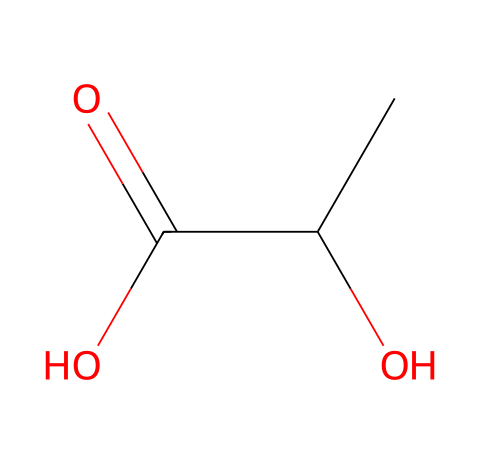What is the name of this chemical? This chemical structure represents lactic acid, which is a common organic acid produced during anaerobic respiration in muscles during intense exercise.
Answer: lactic acid How many carbon atoms are present in lactic acid? By examining the chemical structure, we notice that there are three carbon atoms indicated by the 'C' symbols.
Answer: three What type of functional group is present in lactic acid? The presence of the -COOH group (carboxylic acid) indicates that lactic acid is an acid; this is a characteristic functional group in organic acids.
Answer: carboxylic acid What is the total number of oxygen atoms in lactic acid? In the SMILES structure, there are two 'O' symbols, each representing an oxygen atom, leading to a total of two oxygen atoms in lactic acid.
Answer: two Can lactic acid be classified as a monomer? Yes, lactic acid can be classified as a monomer as it can polymerize to form polylactic acid (PLA), which is used in biodegradable plastics.
Answer: yes What is the significance of lactic acid during intense exercise? Lactic acid accumulates in the muscles during strenuous exercise when oxygen levels are low, causing fatigue and pain, which is why it is monitored in sports science.
Answer: fatigue 